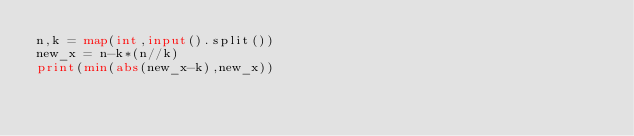<code> <loc_0><loc_0><loc_500><loc_500><_Python_>n,k = map(int,input().split())
new_x = n-k*(n//k)
print(min(abs(new_x-k),new_x))
</code> 